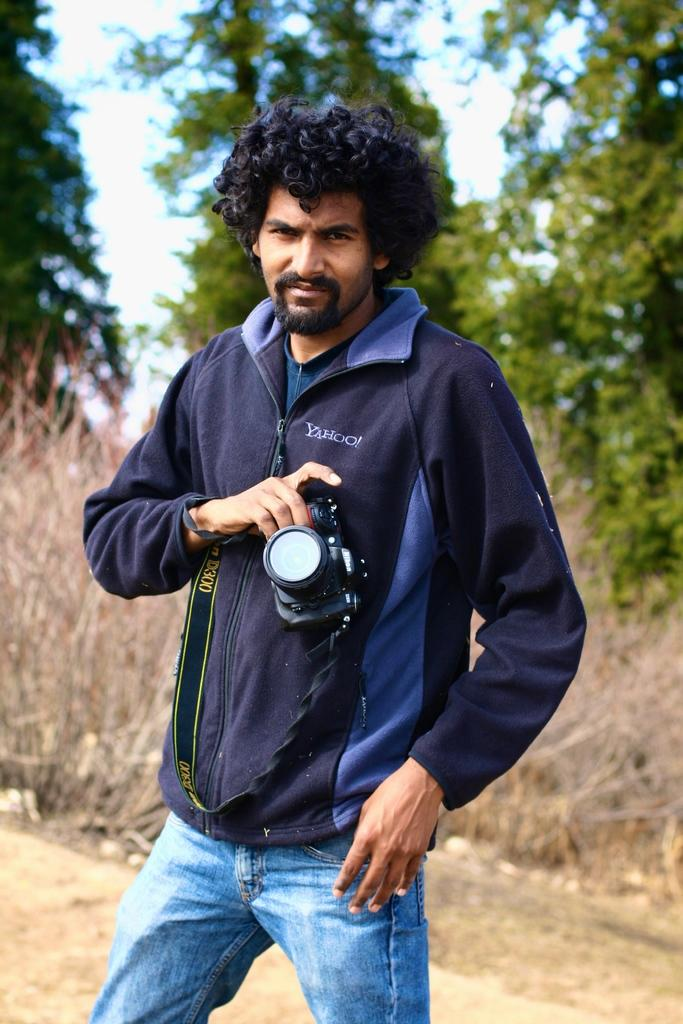Who is present in the image? There is a man in the image. What is the man wearing? The man is wearing a sweatshirt. What is the man holding in the image? The man is holding a camera. What can be seen in the background of the image? There are trees in the background of the image. What type of riddle can be seen carved into the basin in the image? There is no basin present in the image, and therefore no riddle can be seen. 